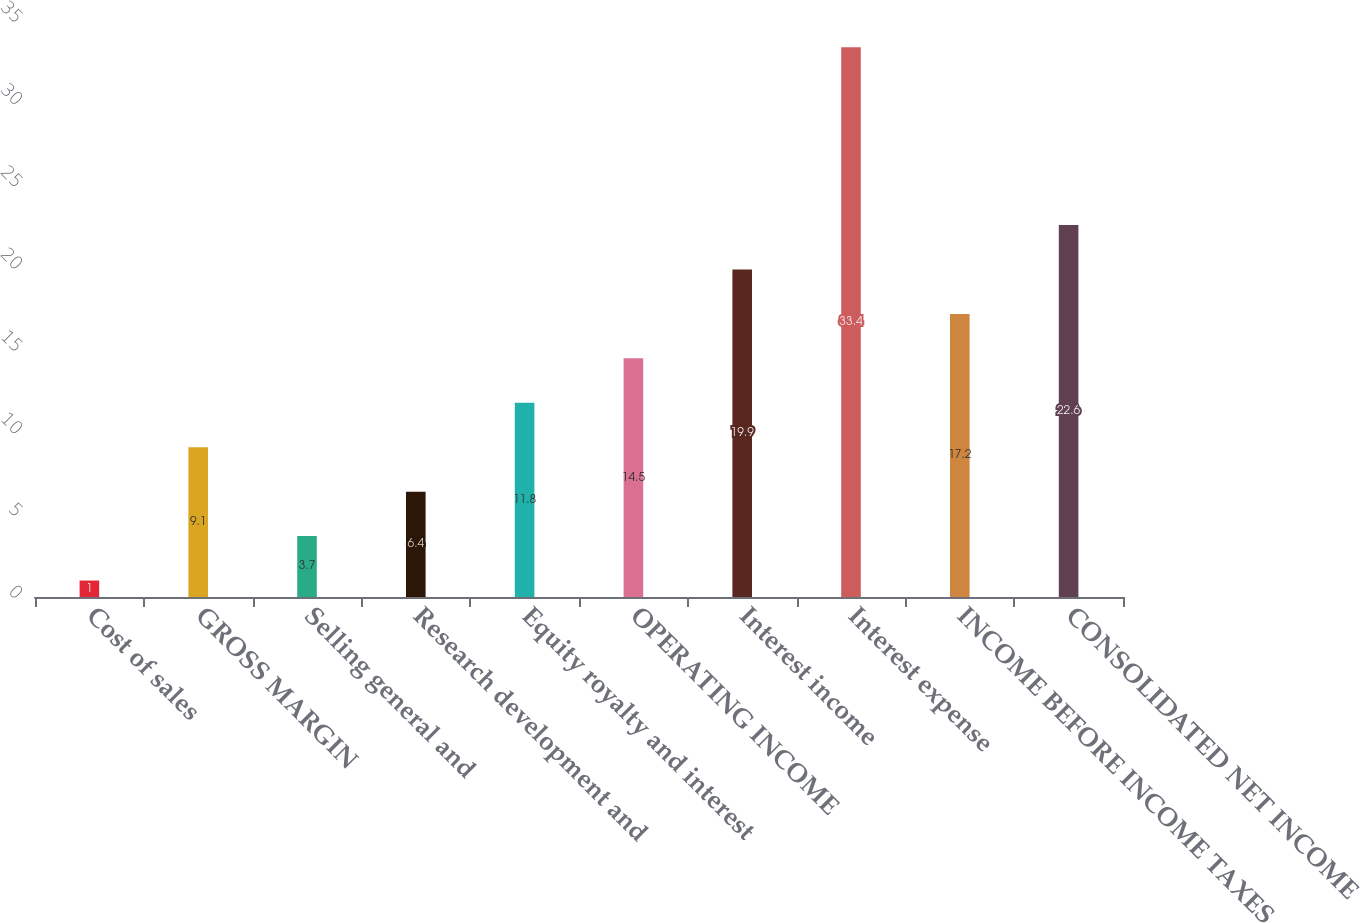Convert chart. <chart><loc_0><loc_0><loc_500><loc_500><bar_chart><fcel>Cost of sales<fcel>GROSS MARGIN<fcel>Selling general and<fcel>Research development and<fcel>Equity royalty and interest<fcel>OPERATING INCOME<fcel>Interest income<fcel>Interest expense<fcel>INCOME BEFORE INCOME TAXES<fcel>CONSOLIDATED NET INCOME<nl><fcel>1<fcel>9.1<fcel>3.7<fcel>6.4<fcel>11.8<fcel>14.5<fcel>19.9<fcel>33.4<fcel>17.2<fcel>22.6<nl></chart> 